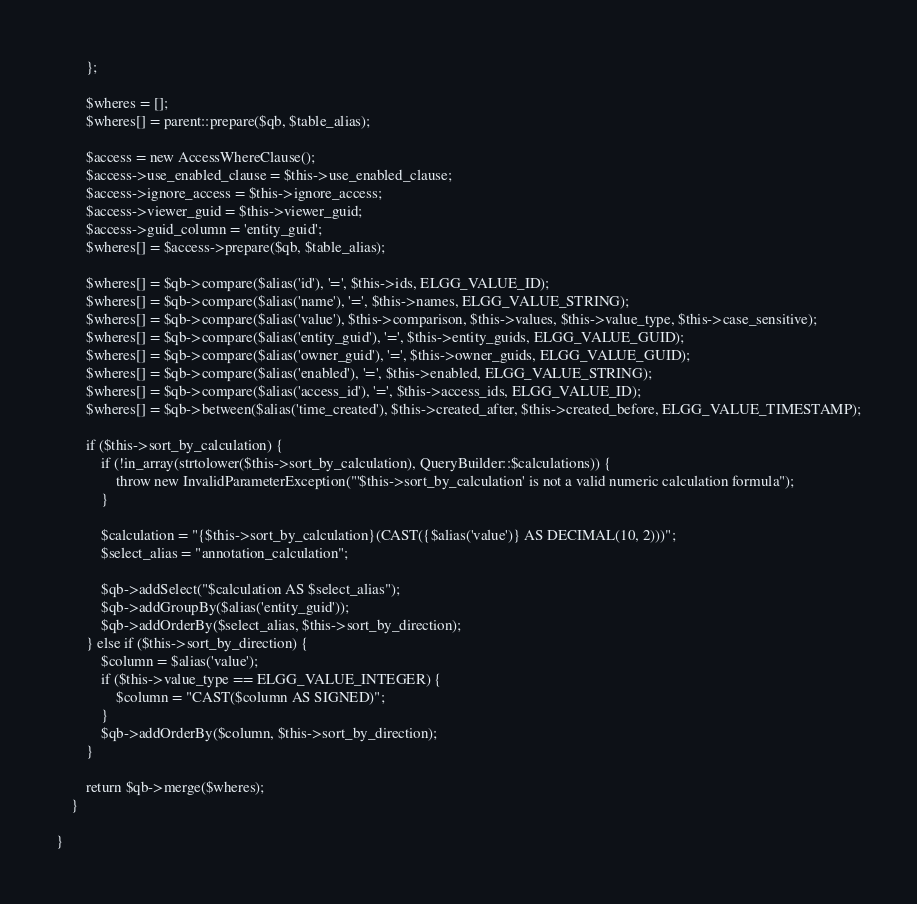Convert code to text. <code><loc_0><loc_0><loc_500><loc_500><_PHP_>		};

		$wheres = [];
		$wheres[] = parent::prepare($qb, $table_alias);

		$access = new AccessWhereClause();
		$access->use_enabled_clause = $this->use_enabled_clause;
		$access->ignore_access = $this->ignore_access;
		$access->viewer_guid = $this->viewer_guid;
		$access->guid_column = 'entity_guid';
		$wheres[] = $access->prepare($qb, $table_alias);

		$wheres[] = $qb->compare($alias('id'), '=', $this->ids, ELGG_VALUE_ID);
		$wheres[] = $qb->compare($alias('name'), '=', $this->names, ELGG_VALUE_STRING);
		$wheres[] = $qb->compare($alias('value'), $this->comparison, $this->values, $this->value_type, $this->case_sensitive);
		$wheres[] = $qb->compare($alias('entity_guid'), '=', $this->entity_guids, ELGG_VALUE_GUID);
		$wheres[] = $qb->compare($alias('owner_guid'), '=', $this->owner_guids, ELGG_VALUE_GUID);
		$wheres[] = $qb->compare($alias('enabled'), '=', $this->enabled, ELGG_VALUE_STRING);
		$wheres[] = $qb->compare($alias('access_id'), '=', $this->access_ids, ELGG_VALUE_ID);
		$wheres[] = $qb->between($alias('time_created'), $this->created_after, $this->created_before, ELGG_VALUE_TIMESTAMP);

		if ($this->sort_by_calculation) {
			if (!in_array(strtolower($this->sort_by_calculation), QueryBuilder::$calculations)) {
				throw new InvalidParameterException("'$this->sort_by_calculation' is not a valid numeric calculation formula");
			}

			$calculation = "{$this->sort_by_calculation}(CAST({$alias('value')} AS DECIMAL(10, 2)))";
			$select_alias = "annotation_calculation";

			$qb->addSelect("$calculation AS $select_alias");
			$qb->addGroupBy($alias('entity_guid'));
			$qb->addOrderBy($select_alias, $this->sort_by_direction);
		} else if ($this->sort_by_direction) {
			$column = $alias('value');
			if ($this->value_type == ELGG_VALUE_INTEGER) {
				$column = "CAST($column AS SIGNED)";
			}
			$qb->addOrderBy($column, $this->sort_by_direction);
		}

		return $qb->merge($wheres);
	}

}
</code> 